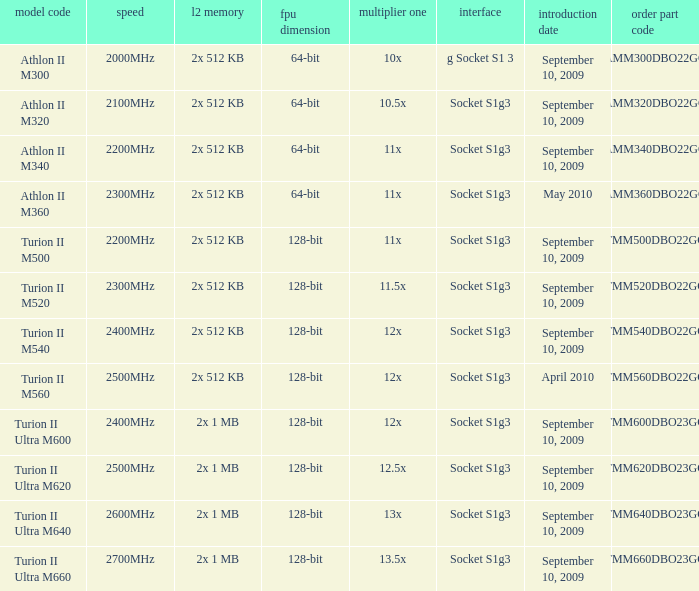What is the order part number with a 12.5x multi 1? TMM620DBO23GQ. 